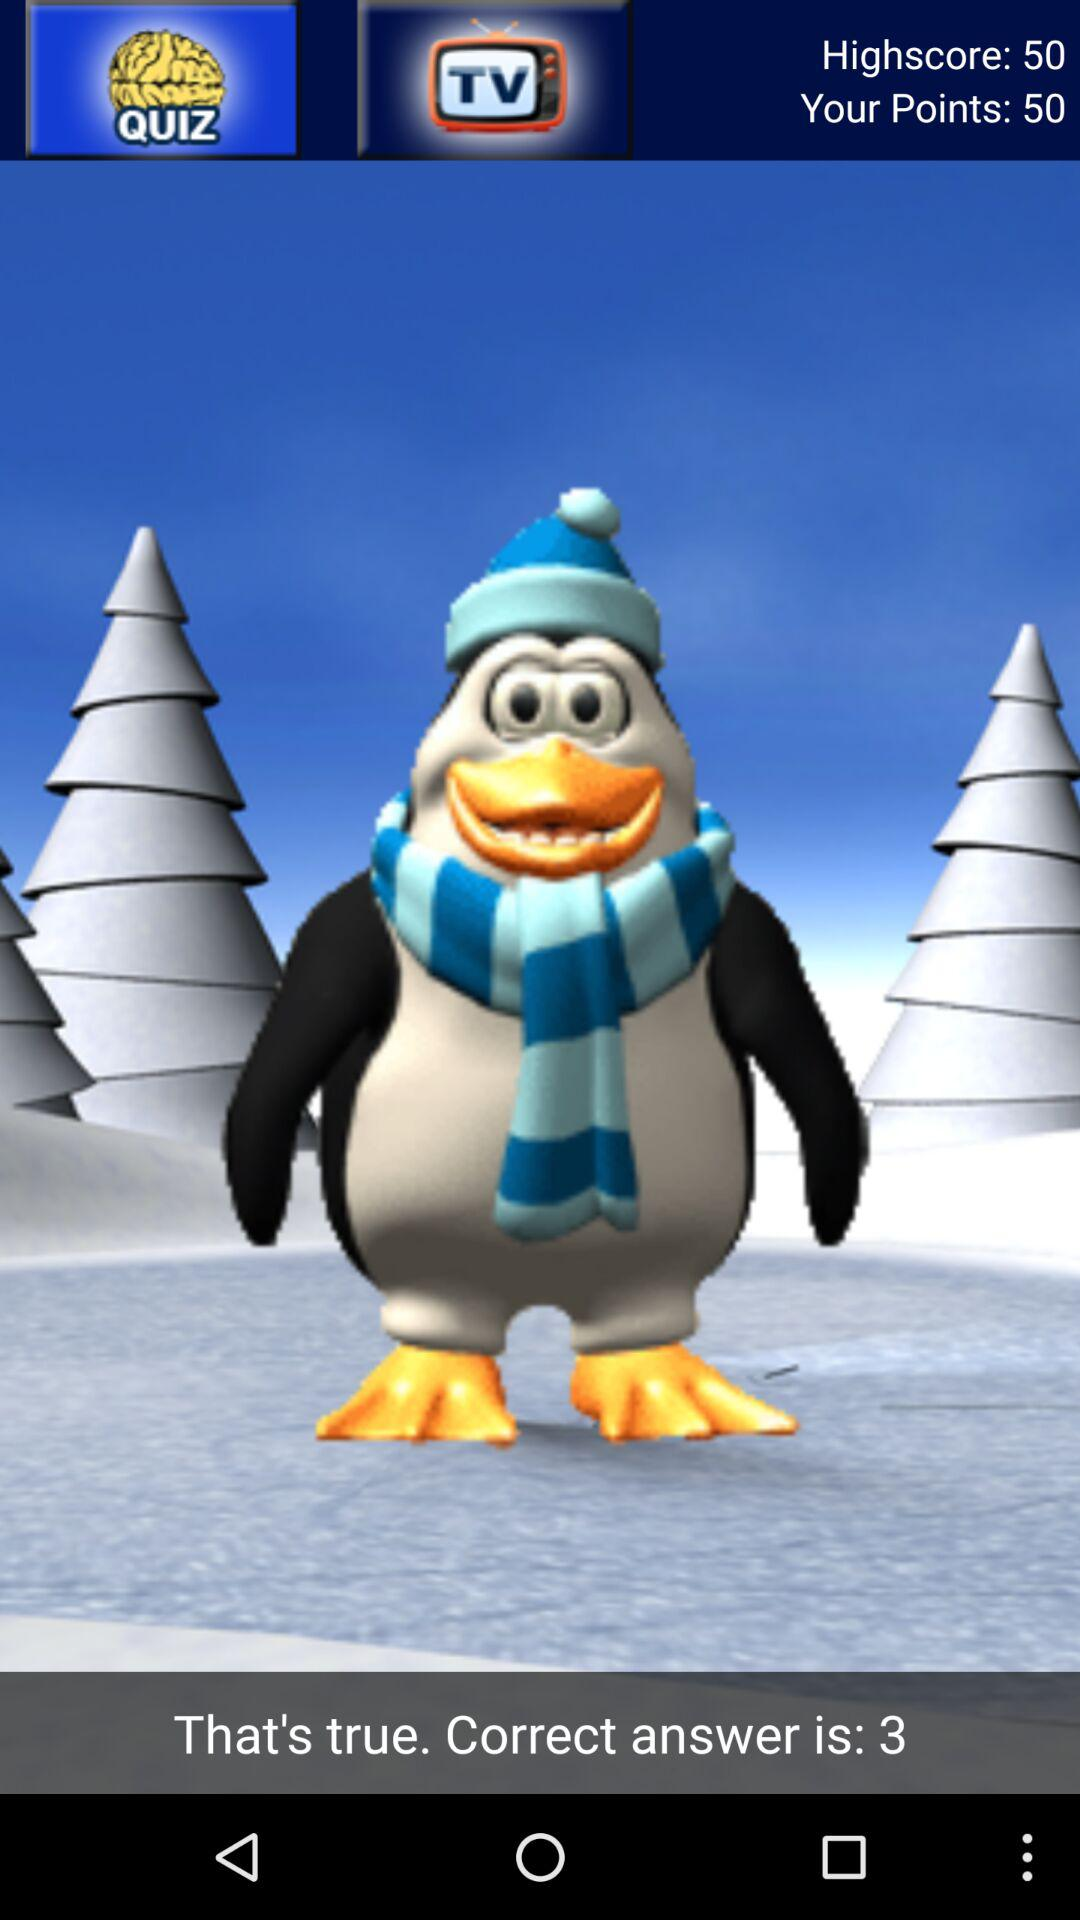How many more points does the user have than their highscore?
Answer the question using a single word or phrase. 0 